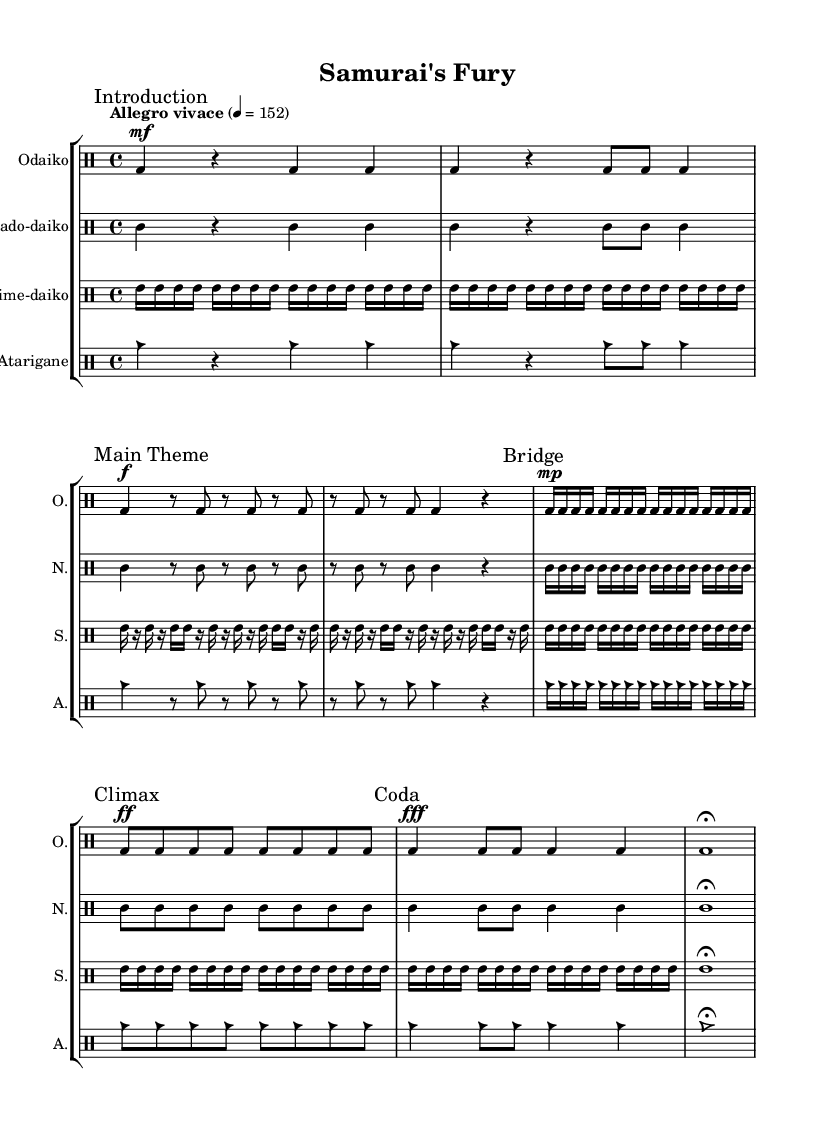What is the key signature of this music? The key signature is C minor, which has three flats (B♭, E♭, A♭) due to the notation shown at the beginning of the score.
Answer: C minor What is the time signature of the piece? The time signature is 4/4, which indicates there are four beats in a measure and the quarter note receives one beat, as displayed at the start of the music.
Answer: 4/4 What is the tempo marking for this piece? The tempo marking is "Allegro vivace," indicating a fast and lively pace for the piece, as stated at the top of the score along with the metronome marking of 152.
Answer: Allegro vivace How many sections are in the composition? The composition contains five sections: Introduction, Main Theme, Bridge, Climax, and Coda, which are clearly marked throughout the sheet music.
Answer: Five Which instrument plays the main theme with the highest volume? The Odaiko plays the main theme marked with a forte dynamic (f), which indicates a louder playing, highlighted in the sheet music where it first introduces the theme.
Answer: Odaiko What rhythmic element is emphasized during the Climax section? During the Climax section, the rhythmic element that is emphasized is the strong, consistent beats from the Odaiko, making it powerful and driving, as indicated by the use of eight notes at a specified dynamic.
Answer: Strong beats Which instrument is used for the highest pitched rhythmic layer in the score? The instrument used for the highest pitched rhythmic layer is the Shime-daiko, which produces higher pitched tones compared to the other drums in the composition, as evidenced by the notation shown.
Answer: Shime-daiko 